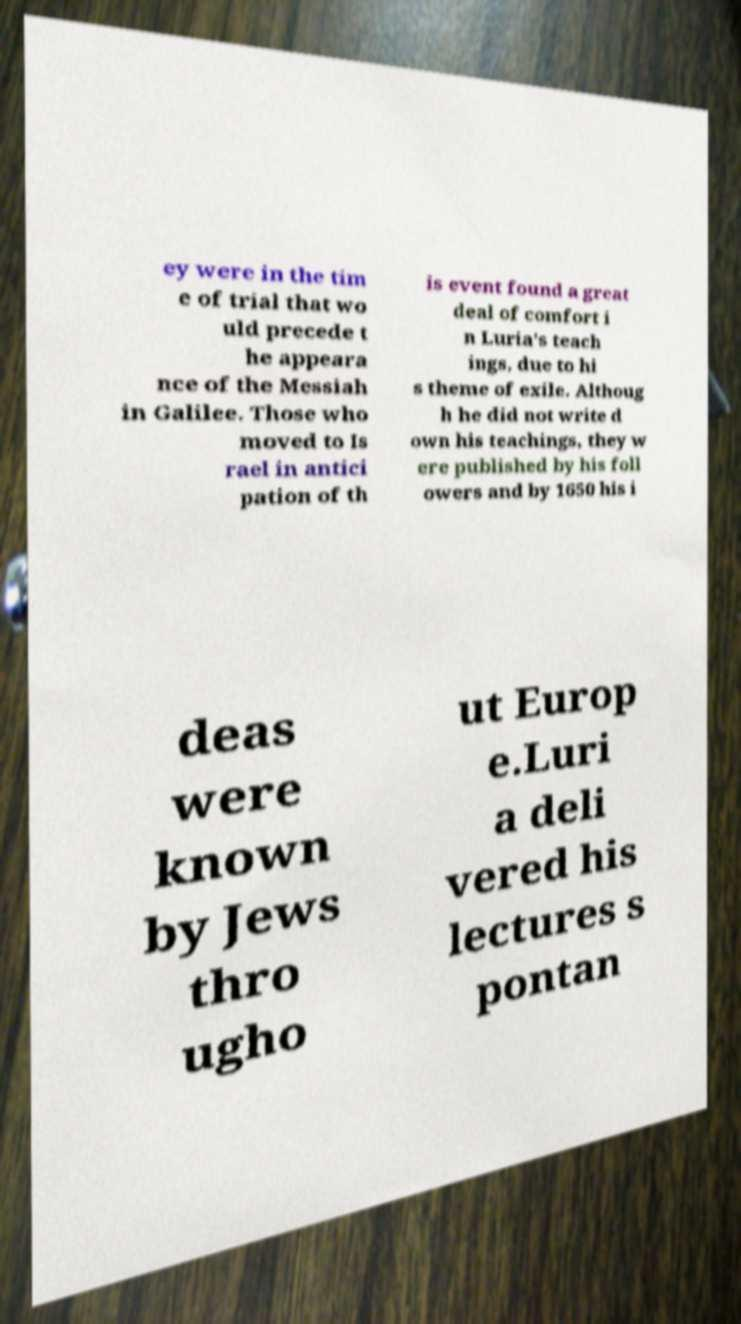What messages or text are displayed in this image? I need them in a readable, typed format. ey were in the tim e of trial that wo uld precede t he appeara nce of the Messiah in Galilee. Those who moved to Is rael in antici pation of th is event found a great deal of comfort i n Luria's teach ings, due to hi s theme of exile. Althoug h he did not write d own his teachings, they w ere published by his foll owers and by 1650 his i deas were known by Jews thro ugho ut Europ e.Luri a deli vered his lectures s pontan 